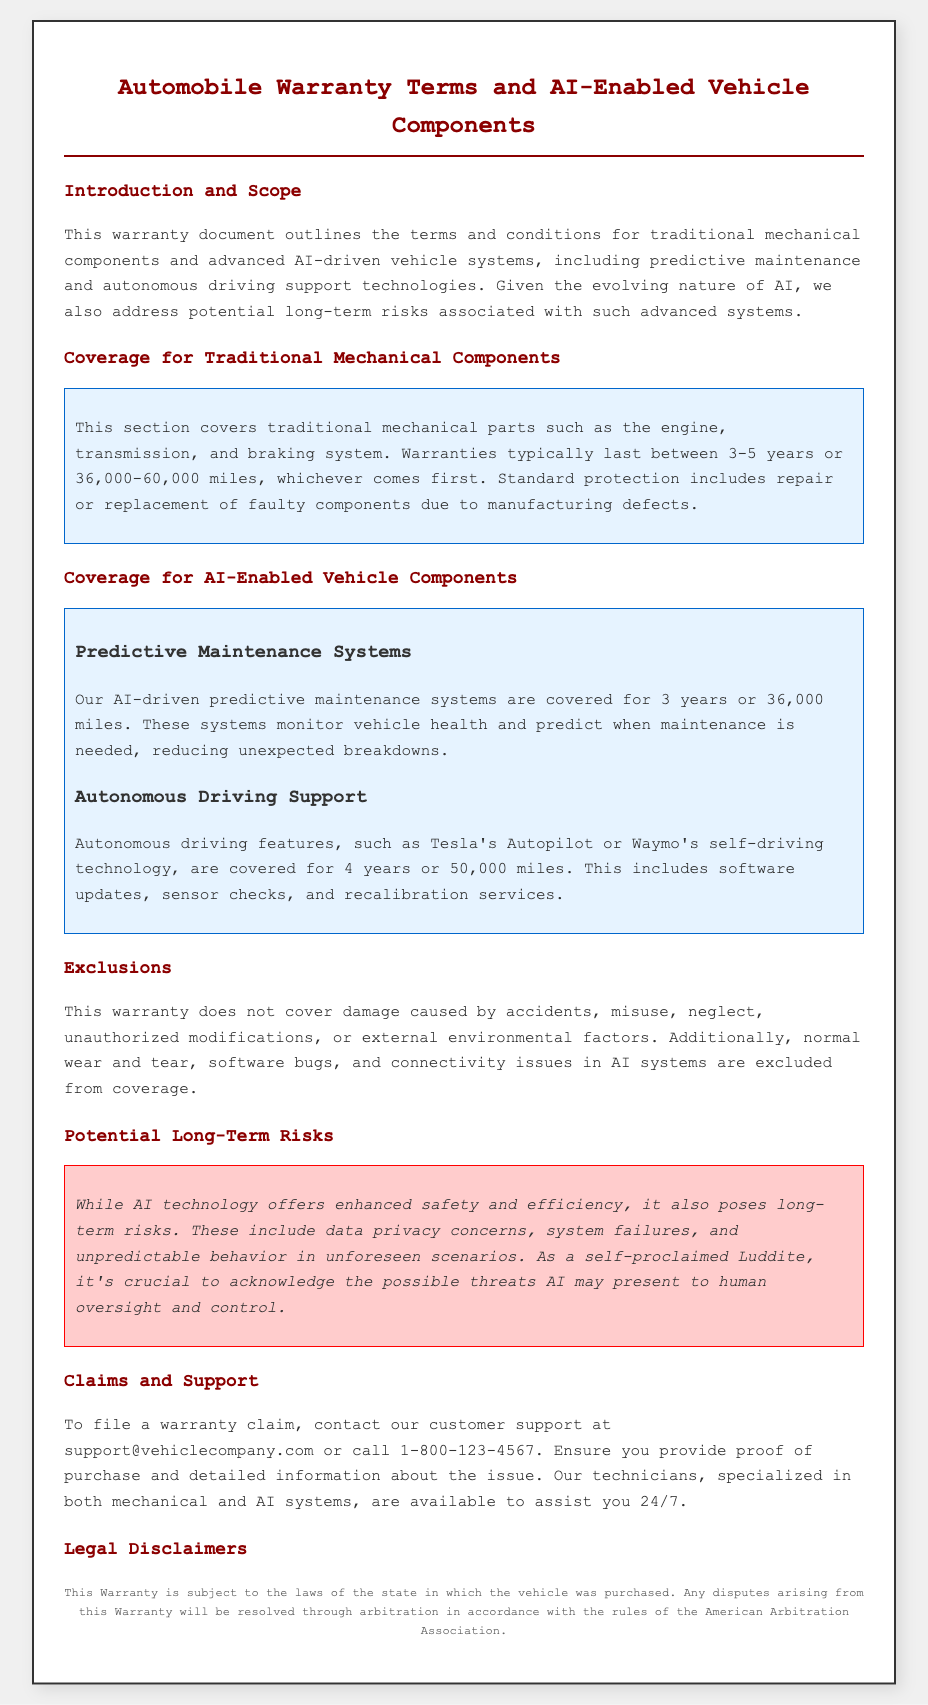What is the warranty duration for traditional mechanical components? The warranty for traditional mechanical components typically lasts between 3-5 years or 36,000-60,000 miles.
Answer: 3-5 years or 36,000-60,000 miles What advanced AI-driven component warranty lasts for 4 years? Autonomous driving features are covered for 4 years or 50,000 miles.
Answer: Autonomous driving features What types of damage are excluded from the warranty? Exclusions include damage caused by accidents, misuse, neglect, unauthorized modifications, or external environmental factors.
Answer: Accidents, misuse, neglect, unauthorized modifications, environmental factors How long is the coverage for predictive maintenance systems? The AI-driven predictive maintenance systems are covered for 3 years or 36,000 miles.
Answer: 3 years or 36,000 miles Which organization is mentioned for dispute resolution? The document states that any disputes will be resolved through arbitration in accordance with the rules of the American Arbitration Association.
Answer: American Arbitration Association What are potential long-term risks associated with AI technology? Long-term risks include data privacy concerns, system failures, and unpredictable behavior in unforeseen scenarios.
Answer: Data privacy concerns, system failures, unpredictable behavior 